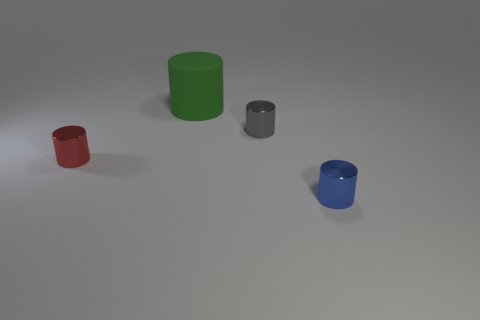Subtract 1 cylinders. How many cylinders are left? 3 Add 2 big purple cylinders. How many objects exist? 6 Add 4 gray cylinders. How many gray cylinders are left? 5 Add 3 tiny blue metal cylinders. How many tiny blue metal cylinders exist? 4 Subtract 1 blue cylinders. How many objects are left? 3 Subtract all big gray matte cubes. Subtract all shiny objects. How many objects are left? 1 